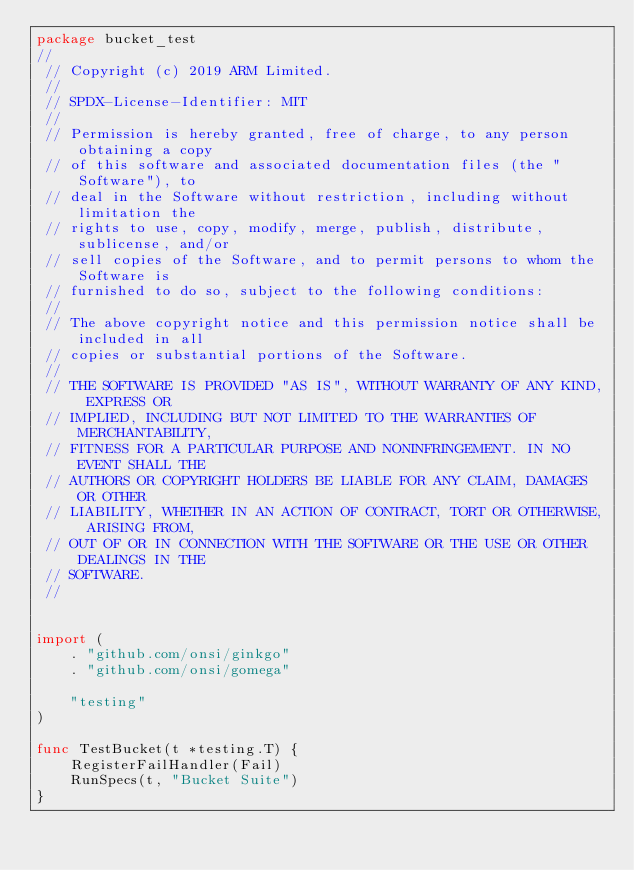Convert code to text. <code><loc_0><loc_0><loc_500><loc_500><_Go_>package bucket_test
//
 // Copyright (c) 2019 ARM Limited.
 //
 // SPDX-License-Identifier: MIT
 //
 // Permission is hereby granted, free of charge, to any person obtaining a copy
 // of this software and associated documentation files (the "Software"), to
 // deal in the Software without restriction, including without limitation the
 // rights to use, copy, modify, merge, publish, distribute, sublicense, and/or
 // sell copies of the Software, and to permit persons to whom the Software is
 // furnished to do so, subject to the following conditions:
 //
 // The above copyright notice and this permission notice shall be included in all
 // copies or substantial portions of the Software.
 //
 // THE SOFTWARE IS PROVIDED "AS IS", WITHOUT WARRANTY OF ANY KIND, EXPRESS OR
 // IMPLIED, INCLUDING BUT NOT LIMITED TO THE WARRANTIES OF MERCHANTABILITY,
 // FITNESS FOR A PARTICULAR PURPOSE AND NONINFRINGEMENT. IN NO EVENT SHALL THE
 // AUTHORS OR COPYRIGHT HOLDERS BE LIABLE FOR ANY CLAIM, DAMAGES OR OTHER
 // LIABILITY, WHETHER IN AN ACTION OF CONTRACT, TORT OR OTHERWISE, ARISING FROM,
 // OUT OF OR IN CONNECTION WITH THE SOFTWARE OR THE USE OR OTHER DEALINGS IN THE
 // SOFTWARE.
 //


import (
    . "github.com/onsi/ginkgo"
    . "github.com/onsi/gomega"

    "testing"
)

func TestBucket(t *testing.T) {
    RegisterFailHandler(Fail)
    RunSpecs(t, "Bucket Suite")
}
</code> 